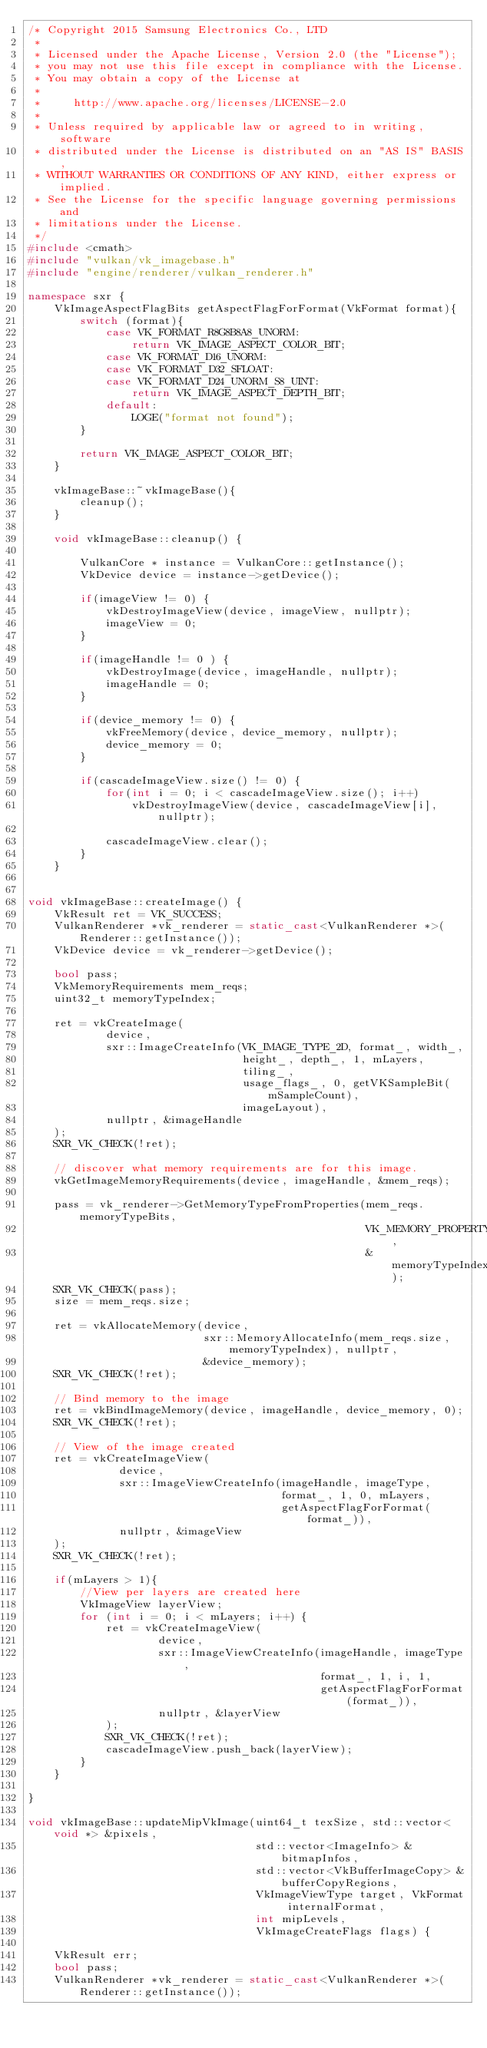<code> <loc_0><loc_0><loc_500><loc_500><_C++_>/* Copyright 2015 Samsung Electronics Co., LTD
 *
 * Licensed under the Apache License, Version 2.0 (the "License");
 * you may not use this file except in compliance with the License.
 * You may obtain a copy of the License at
 *
 *     http://www.apache.org/licenses/LICENSE-2.0
 *
 * Unless required by applicable law or agreed to in writing, software
 * distributed under the License is distributed on an "AS IS" BASIS,
 * WITHOUT WARRANTIES OR CONDITIONS OF ANY KIND, either express or implied.
 * See the License for the specific language governing permissions and
 * limitations under the License.
 */
#include <cmath>
#include "vulkan/vk_imagebase.h"
#include "engine/renderer/vulkan_renderer.h"

namespace sxr {
    VkImageAspectFlagBits getAspectFlagForFormat(VkFormat format){
        switch (format){
            case VK_FORMAT_R8G8B8A8_UNORM:
                return VK_IMAGE_ASPECT_COLOR_BIT;
            case VK_FORMAT_D16_UNORM:
            case VK_FORMAT_D32_SFLOAT:
            case VK_FORMAT_D24_UNORM_S8_UINT:
                return VK_IMAGE_ASPECT_DEPTH_BIT;
            default:
                LOGE("format not found");
        }

        return VK_IMAGE_ASPECT_COLOR_BIT;
    }

    vkImageBase::~vkImageBase(){
        cleanup();
    }

    void vkImageBase::cleanup() {

        VulkanCore * instance = VulkanCore::getInstance();
        VkDevice device = instance->getDevice();

        if(imageView != 0) {
            vkDestroyImageView(device, imageView, nullptr);
            imageView = 0;
        }

        if(imageHandle != 0 ) {
            vkDestroyImage(device, imageHandle, nullptr);
            imageHandle = 0;
        }

        if(device_memory != 0) {
            vkFreeMemory(device, device_memory, nullptr);
            device_memory = 0;
        }

        if(cascadeImageView.size() != 0) {
            for(int i = 0; i < cascadeImageView.size(); i++)
                vkDestroyImageView(device, cascadeImageView[i], nullptr);

            cascadeImageView.clear();
        }
    }


void vkImageBase::createImage() {
    VkResult ret = VK_SUCCESS;
    VulkanRenderer *vk_renderer = static_cast<VulkanRenderer *>(Renderer::getInstance());
    VkDevice device = vk_renderer->getDevice();

    bool pass;
    VkMemoryRequirements mem_reqs;
    uint32_t memoryTypeIndex;

    ret = vkCreateImage(
            device,
            sxr::ImageCreateInfo(VK_IMAGE_TYPE_2D, format_, width_,
                                 height_, depth_, 1, mLayers,
                                 tiling_,
                                 usage_flags_, 0, getVKSampleBit(mSampleCount),
                                 imageLayout),
            nullptr, &imageHandle
    );
    SXR_VK_CHECK(!ret);

    // discover what memory requirements are for this image.
    vkGetImageMemoryRequirements(device, imageHandle, &mem_reqs);

    pass = vk_renderer->GetMemoryTypeFromProperties(mem_reqs.memoryTypeBits,
                                                    VK_MEMORY_PROPERTY_DEVICE_LOCAL_BIT,
                                                    &memoryTypeIndex);
    SXR_VK_CHECK(pass);
    size = mem_reqs.size;

    ret = vkAllocateMemory(device,
                           sxr::MemoryAllocateInfo(mem_reqs.size, memoryTypeIndex), nullptr,
                           &device_memory);
    SXR_VK_CHECK(!ret);

    // Bind memory to the image
    ret = vkBindImageMemory(device, imageHandle, device_memory, 0);
    SXR_VK_CHECK(!ret);

    // View of the image created
    ret = vkCreateImageView(
              device,
              sxr::ImageViewCreateInfo(imageHandle, imageType,
                                       format_, 1, 0, mLayers,
                                       getAspectFlagForFormat(format_)),
              nullptr, &imageView
    );
    SXR_VK_CHECK(!ret);

    if(mLayers > 1){
        //View per layers are created here
        VkImageView layerView;
        for (int i = 0; i < mLayers; i++) {
            ret = vkCreateImageView(
                    device,
                    sxr::ImageViewCreateInfo(imageHandle, imageType,
                                             format_, 1, i, 1,
                                             getAspectFlagForFormat(format_)),
                    nullptr, &layerView
            );
            SXR_VK_CHECK(!ret);
            cascadeImageView.push_back(layerView);
        }
    }

}

void vkImageBase::updateMipVkImage(uint64_t texSize, std::vector<void *> &pixels,
                                   std::vector<ImageInfo> &bitmapInfos,
                                   std::vector<VkBufferImageCopy> &bufferCopyRegions,
                                   VkImageViewType target, VkFormat internalFormat,
                                   int mipLevels,
                                   VkImageCreateFlags flags) {

    VkResult err;
    bool pass;
    VulkanRenderer *vk_renderer = static_cast<VulkanRenderer *>(Renderer::getInstance());</code> 